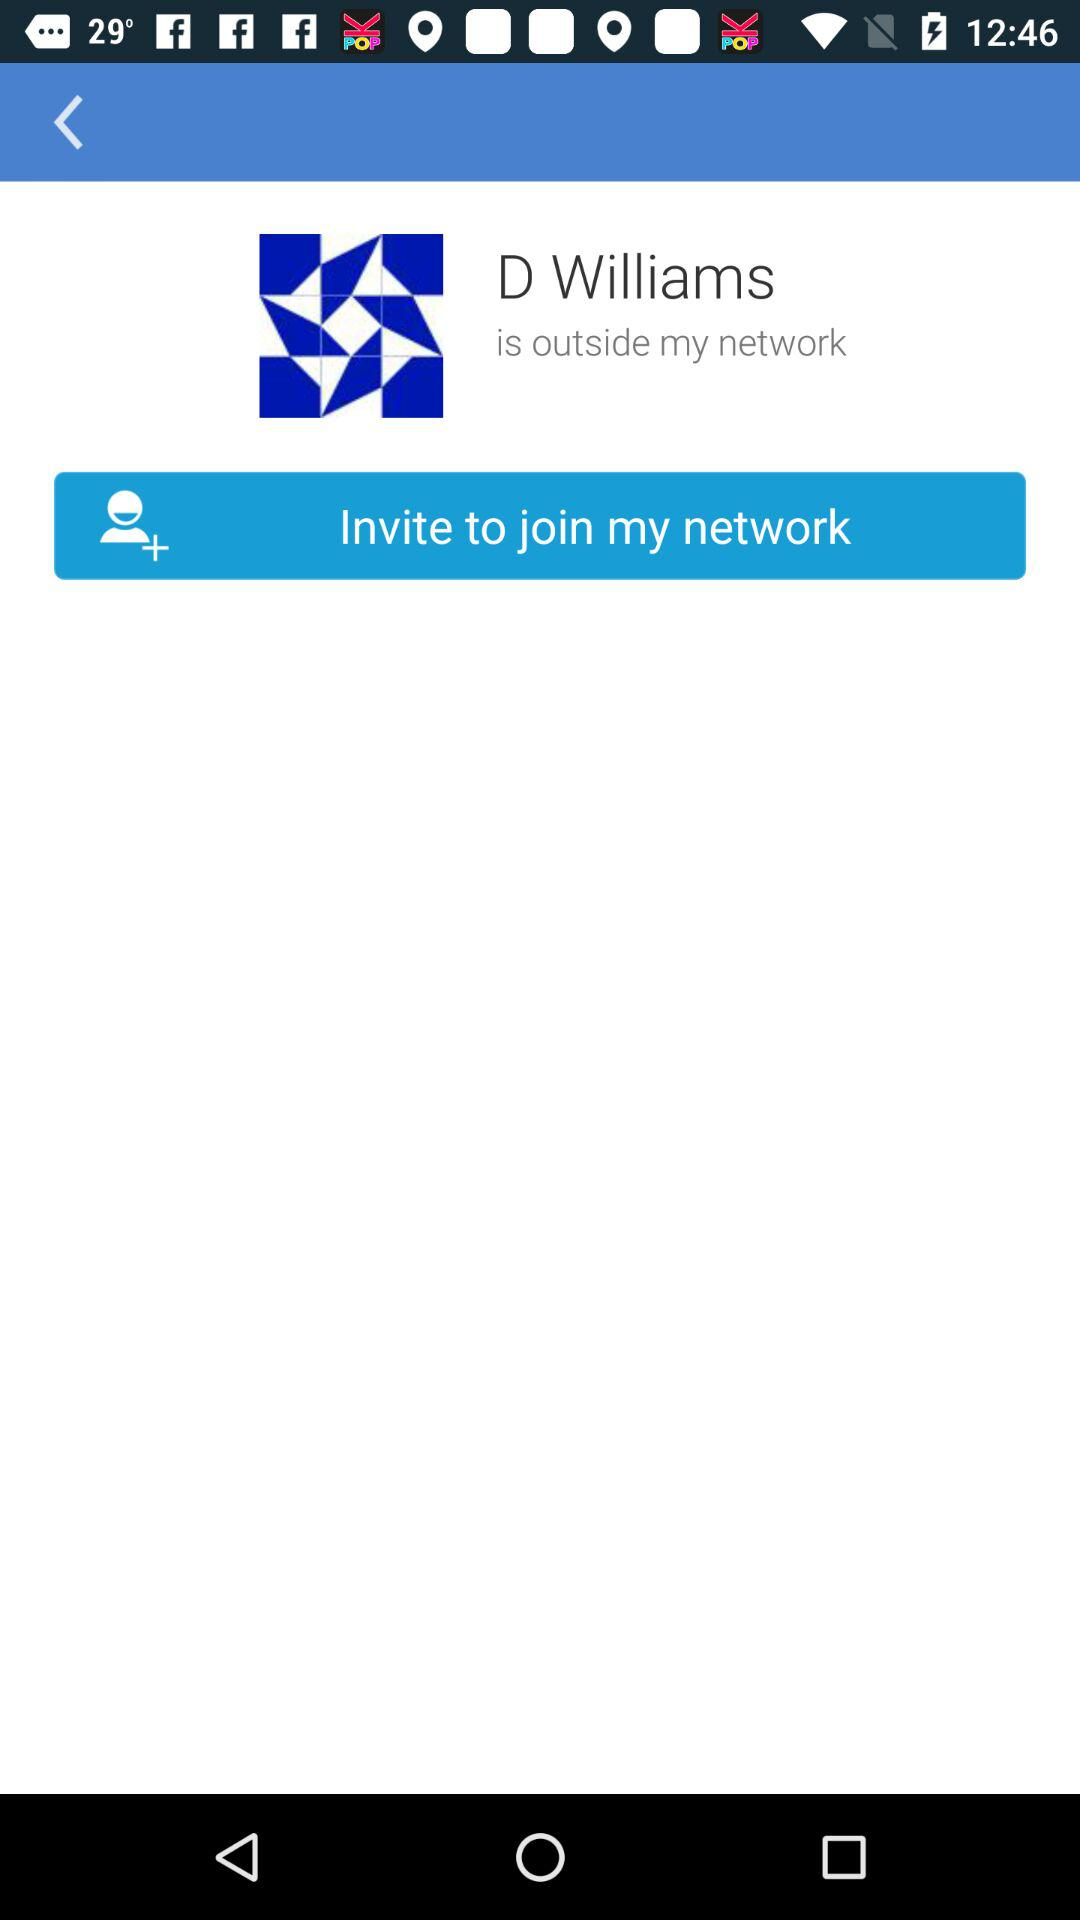How old is "D Williams"?
When the provided information is insufficient, respond with <no answer>. <no answer> 